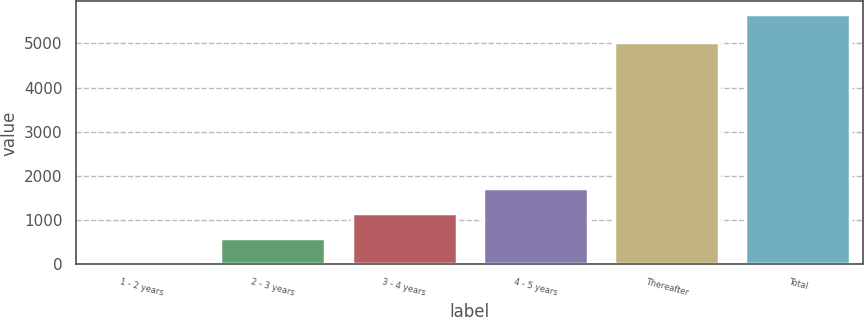<chart> <loc_0><loc_0><loc_500><loc_500><bar_chart><fcel>1 - 2 years<fcel>2 - 3 years<fcel>3 - 4 years<fcel>4 - 5 years<fcel>Thereafter<fcel>Total<nl><fcel>29<fcel>593.4<fcel>1157.8<fcel>1722.2<fcel>5023<fcel>5673<nl></chart> 